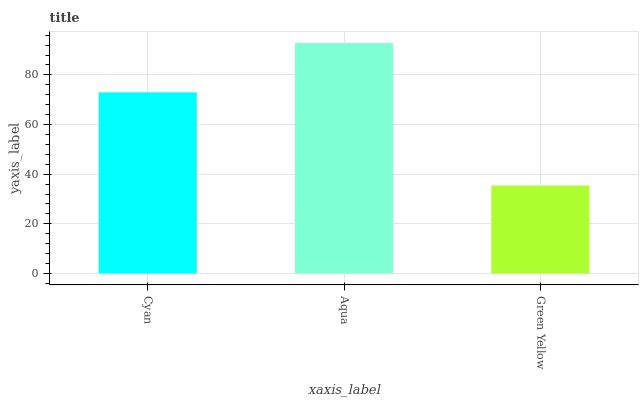Is Green Yellow the minimum?
Answer yes or no. Yes. Is Aqua the maximum?
Answer yes or no. Yes. Is Aqua the minimum?
Answer yes or no. No. Is Green Yellow the maximum?
Answer yes or no. No. Is Aqua greater than Green Yellow?
Answer yes or no. Yes. Is Green Yellow less than Aqua?
Answer yes or no. Yes. Is Green Yellow greater than Aqua?
Answer yes or no. No. Is Aqua less than Green Yellow?
Answer yes or no. No. Is Cyan the high median?
Answer yes or no. Yes. Is Cyan the low median?
Answer yes or no. Yes. Is Aqua the high median?
Answer yes or no. No. Is Aqua the low median?
Answer yes or no. No. 